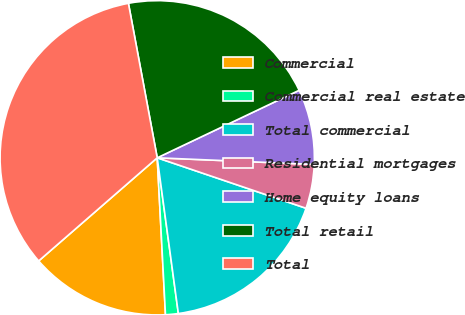Convert chart to OTSL. <chart><loc_0><loc_0><loc_500><loc_500><pie_chart><fcel>Commercial<fcel>Commercial real estate<fcel>Total commercial<fcel>Residential mortgages<fcel>Home equity loans<fcel>Total retail<fcel>Total<nl><fcel>14.44%<fcel>1.31%<fcel>17.65%<fcel>4.53%<fcel>7.74%<fcel>20.87%<fcel>33.46%<nl></chart> 